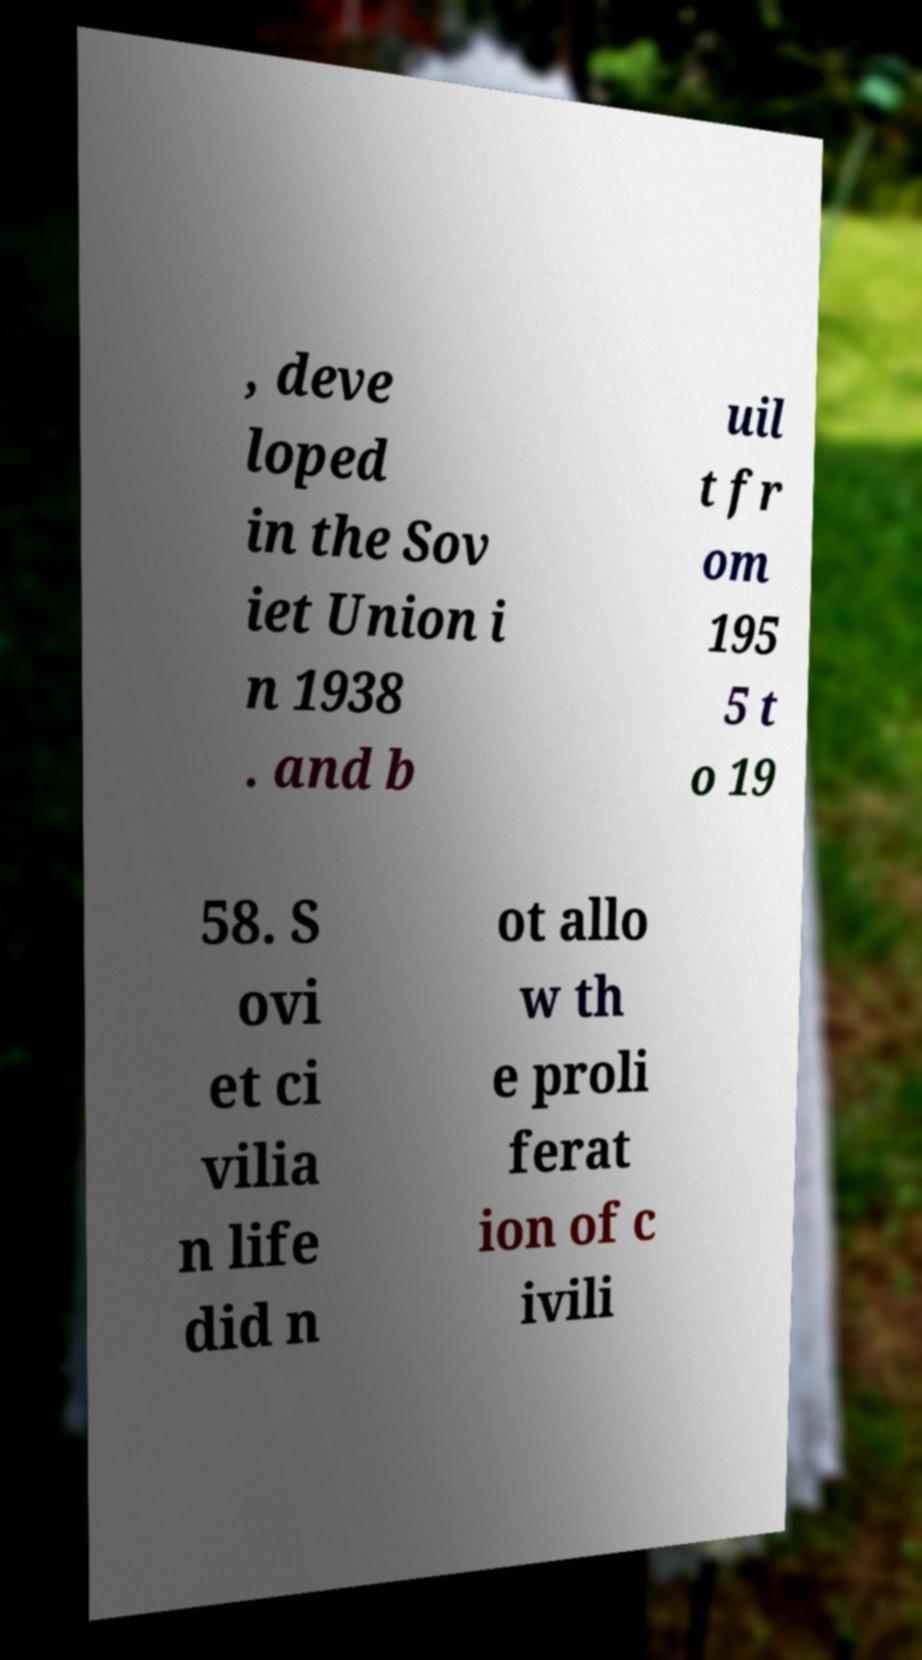For documentation purposes, I need the text within this image transcribed. Could you provide that? , deve loped in the Sov iet Union i n 1938 . and b uil t fr om 195 5 t o 19 58. S ovi et ci vilia n life did n ot allo w th e proli ferat ion of c ivili 